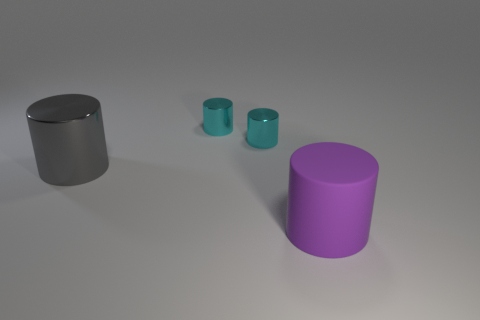Are there any other things that are the same size as the purple matte cylinder?
Offer a very short reply. Yes. Does the rubber object have the same shape as the big gray metal object?
Keep it short and to the point. Yes. Are there fewer cyan metallic objects that are left of the purple matte cylinder than matte objects to the left of the big metal cylinder?
Offer a terse response. No. What number of small metal objects are to the left of the big purple rubber cylinder?
Your answer should be compact. 2. There is a big object behind the rubber object; is it the same shape as the large object that is in front of the big gray cylinder?
Offer a very short reply. Yes. How many other things are the same color as the large rubber cylinder?
Give a very brief answer. 0. What is the material of the cylinder in front of the large cylinder that is behind the large thing to the right of the gray cylinder?
Make the answer very short. Rubber. What material is the large cylinder that is in front of the large thing on the left side of the purple object?
Provide a short and direct response. Rubber. Is the number of cyan metallic cylinders that are right of the purple object less than the number of gray metal things?
Your answer should be very brief. Yes. There is a large thing that is left of the large purple matte thing; what is its shape?
Your answer should be compact. Cylinder. 